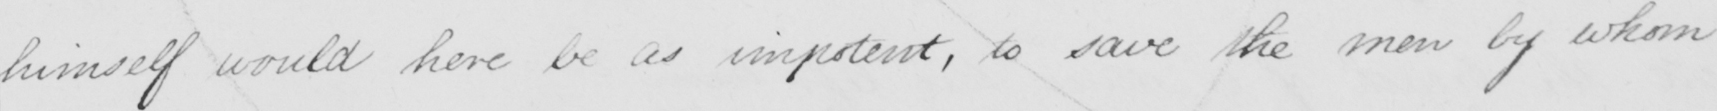Please provide the text content of this handwritten line. himself would here be as impotent , to save the men by whom 